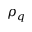Convert formula to latex. <formula><loc_0><loc_0><loc_500><loc_500>\rho _ { q }</formula> 